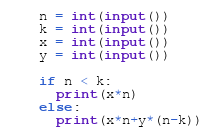<code> <loc_0><loc_0><loc_500><loc_500><_Python_>n = int(input())
k = int(input())
x = int(input())
y = int(input())

if n < k:
  print(x*n)
else:
  print(x*n+y*(n-k))</code> 